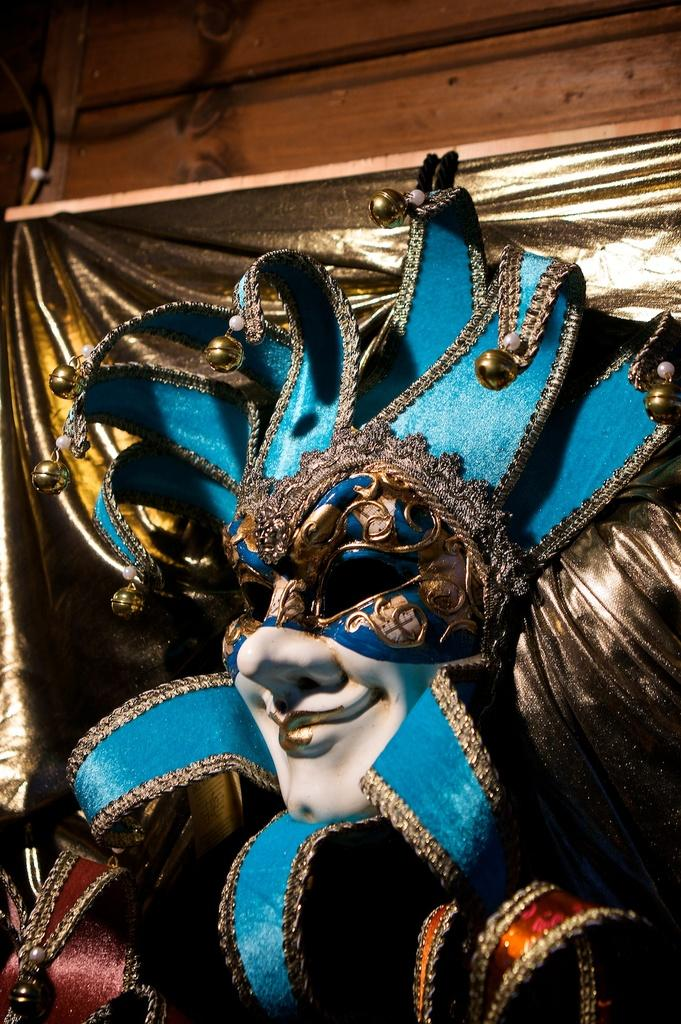What object can be seen in the image? There is a mask in the image. Can you describe any specific features of the mask? The mask has blue detailing. What type of wound can be seen on the mask in the image? There is no wound present on the mask in the image; it is a mask with blue detailing. Is there a hammer visible in the image? No, there is no hammer present in the image. 